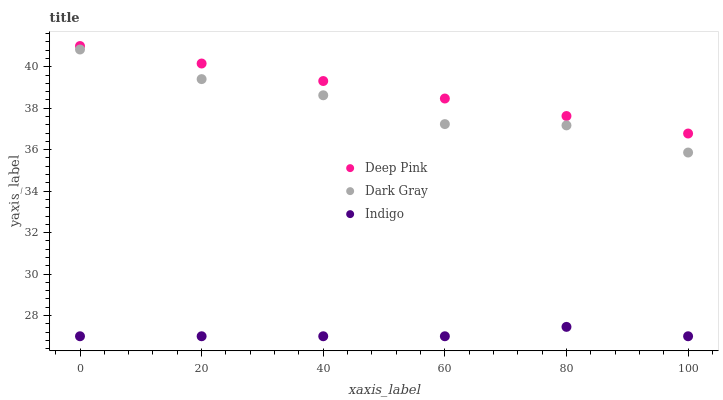Does Indigo have the minimum area under the curve?
Answer yes or no. Yes. Does Deep Pink have the maximum area under the curve?
Answer yes or no. Yes. Does Deep Pink have the minimum area under the curve?
Answer yes or no. No. Does Indigo have the maximum area under the curve?
Answer yes or no. No. Is Deep Pink the smoothest?
Answer yes or no. Yes. Is Dark Gray the roughest?
Answer yes or no. Yes. Is Indigo the smoothest?
Answer yes or no. No. Is Indigo the roughest?
Answer yes or no. No. Does Indigo have the lowest value?
Answer yes or no. Yes. Does Deep Pink have the lowest value?
Answer yes or no. No. Does Deep Pink have the highest value?
Answer yes or no. Yes. Does Indigo have the highest value?
Answer yes or no. No. Is Dark Gray less than Deep Pink?
Answer yes or no. Yes. Is Deep Pink greater than Indigo?
Answer yes or no. Yes. Does Dark Gray intersect Deep Pink?
Answer yes or no. No. 